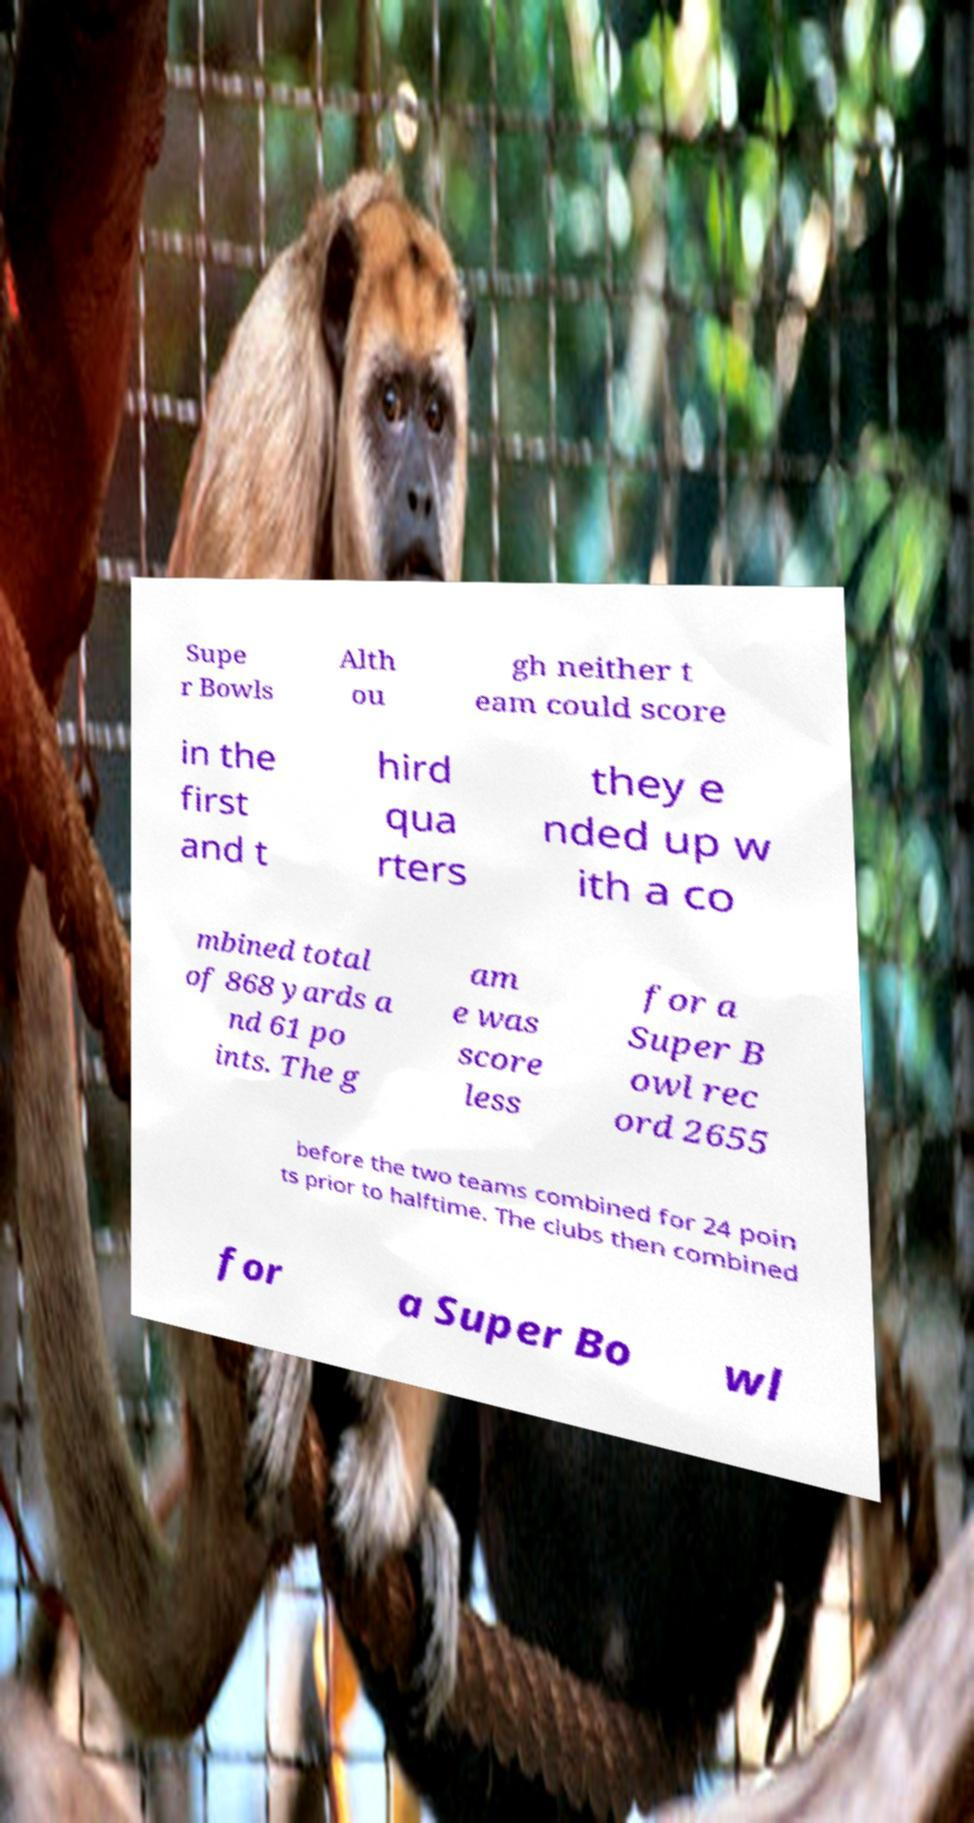There's text embedded in this image that I need extracted. Can you transcribe it verbatim? Supe r Bowls Alth ou gh neither t eam could score in the first and t hird qua rters they e nded up w ith a co mbined total of 868 yards a nd 61 po ints. The g am e was score less for a Super B owl rec ord 2655 before the two teams combined for 24 poin ts prior to halftime. The clubs then combined for a Super Bo wl 